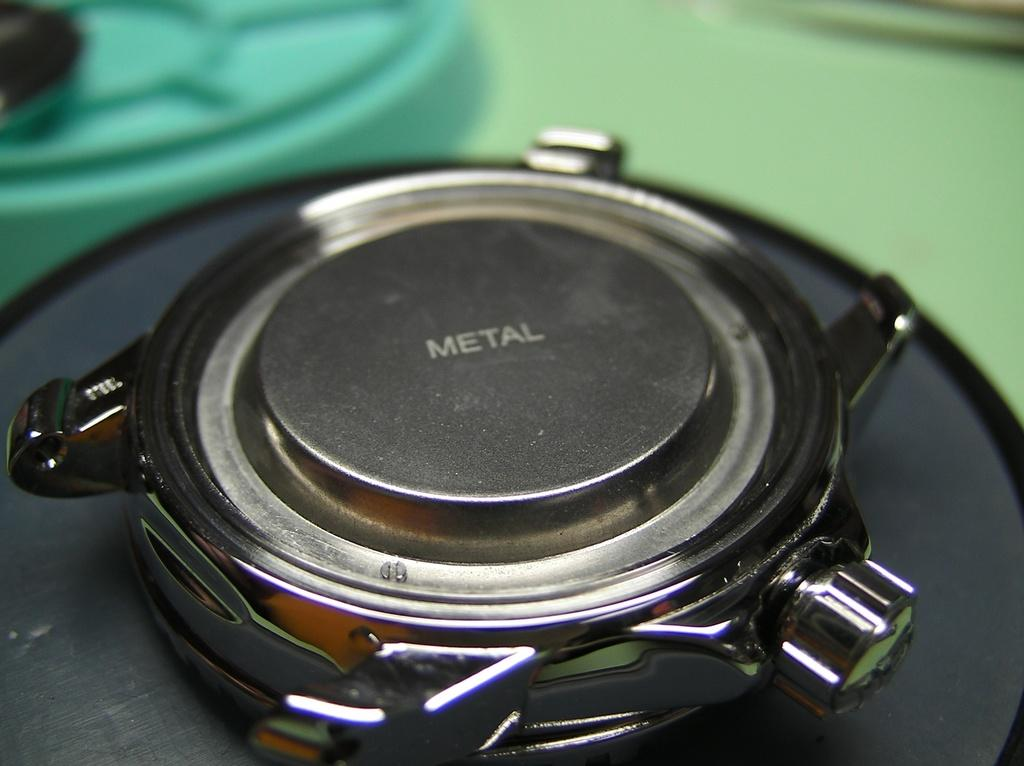<image>
Create a compact narrative representing the image presented. Metal circle that says "METAL" in the middle. 